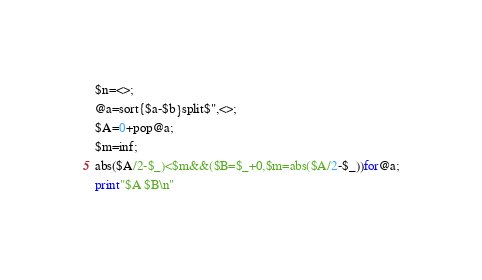<code> <loc_0><loc_0><loc_500><loc_500><_Perl_>$n=<>;
@a=sort{$a-$b}split$",<>;
$A=0+pop@a;
$m=inf;
abs($A/2-$_)<$m&&($B=$_+0,$m=abs($A/2-$_))for@a;
print"$A $B\n"
</code> 